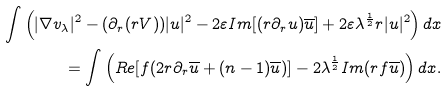<formula> <loc_0><loc_0><loc_500><loc_500>\int \left ( | \nabla v _ { \lambda } | ^ { 2 } - ( \partial _ { r } ( r V ) ) | u | ^ { 2 } - 2 \varepsilon I m [ ( r \partial _ { r } u ) \overline { u } ] + 2 \varepsilon \lambda ^ { \frac { 1 } { 2 } } r | u | ^ { 2 } \right ) d x \\ = \int \left ( R e [ f ( 2 r \partial _ { r } \overline { u } + ( n - 1 ) \overline { u } ) ] - 2 \lambda ^ { \frac { 1 } { 2 } } I m ( r f \overline { u } ) \right ) d x .</formula> 